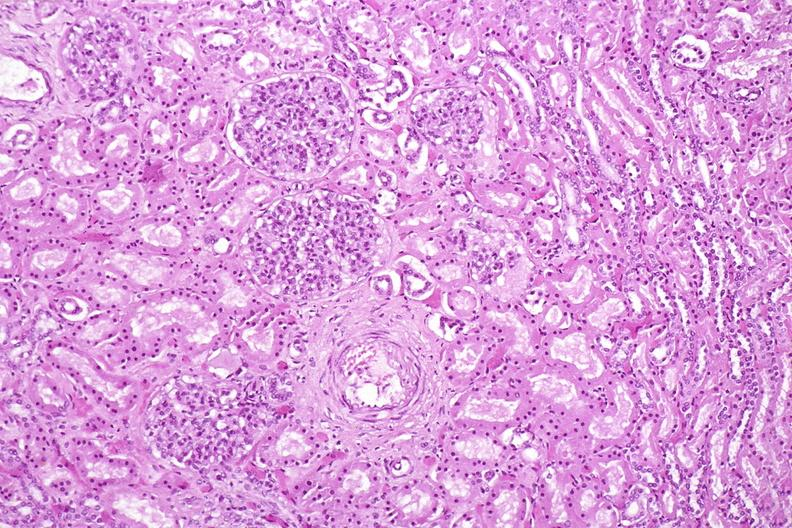does parathyroid show kidney, normal histology?
Answer the question using a single word or phrase. No 